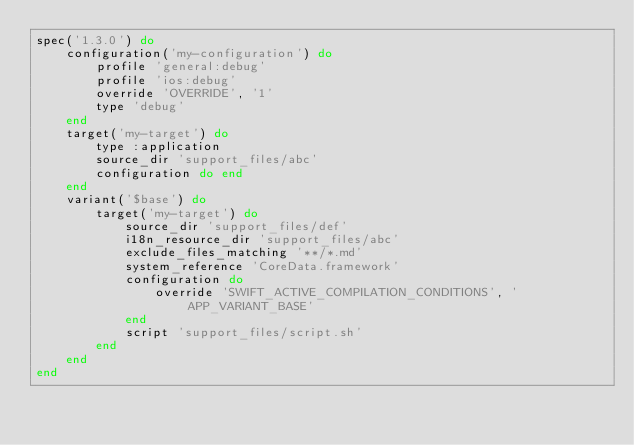Convert code to text. <code><loc_0><loc_0><loc_500><loc_500><_Ruby_>spec('1.3.0') do
	configuration('my-configuration') do
		profile 'general:debug'
		profile 'ios:debug'
		override 'OVERRIDE', '1'
		type 'debug'
	end
	target('my-target') do
		type :application
		source_dir 'support_files/abc'
		configuration do end
	end
	variant('$base') do
		target('my-target') do
			source_dir 'support_files/def'
			i18n_resource_dir 'support_files/abc'
			exclude_files_matching '**/*.md'
			system_reference 'CoreData.framework'
			configuration do
				override 'SWIFT_ACTIVE_COMPILATION_CONDITIONS', 'APP_VARIANT_BASE'
			end
			script 'support_files/script.sh'
		end
	end
end</code> 